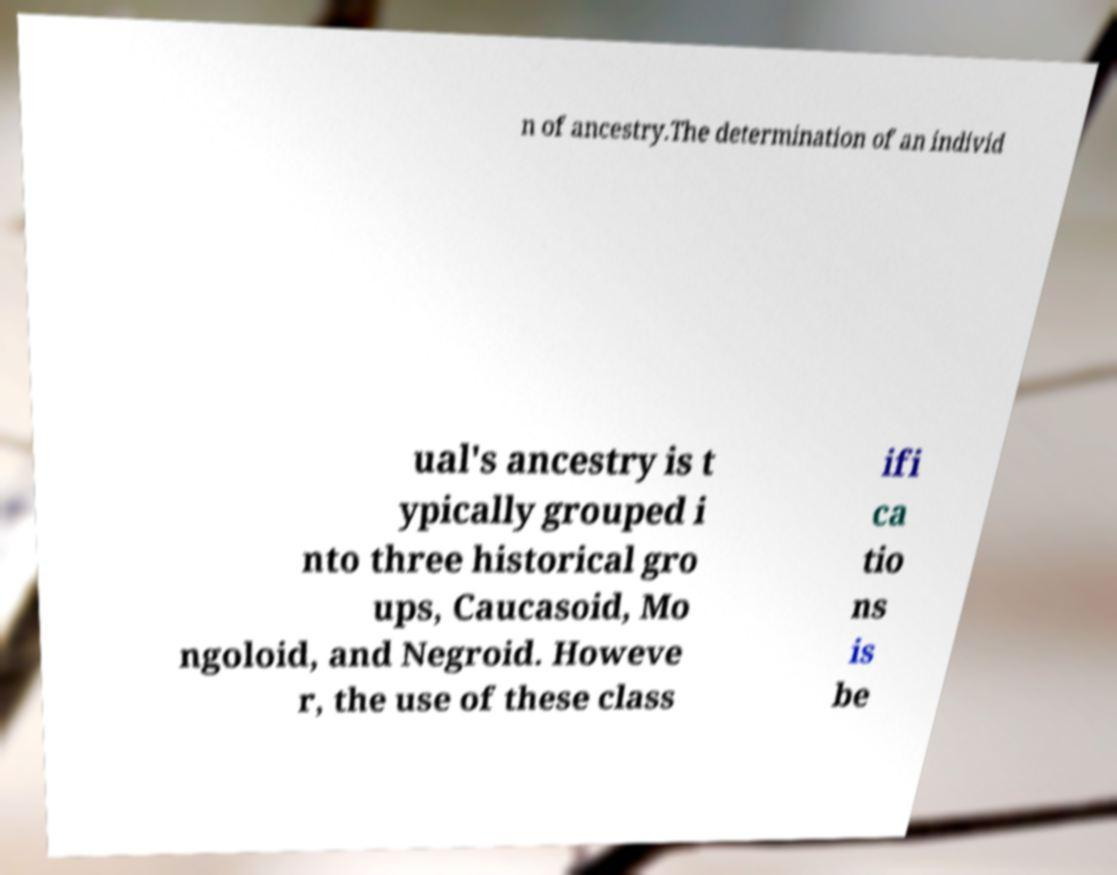Please identify and transcribe the text found in this image. n of ancestry.The determination of an individ ual's ancestry is t ypically grouped i nto three historical gro ups, Caucasoid, Mo ngoloid, and Negroid. Howeve r, the use of these class ifi ca tio ns is be 